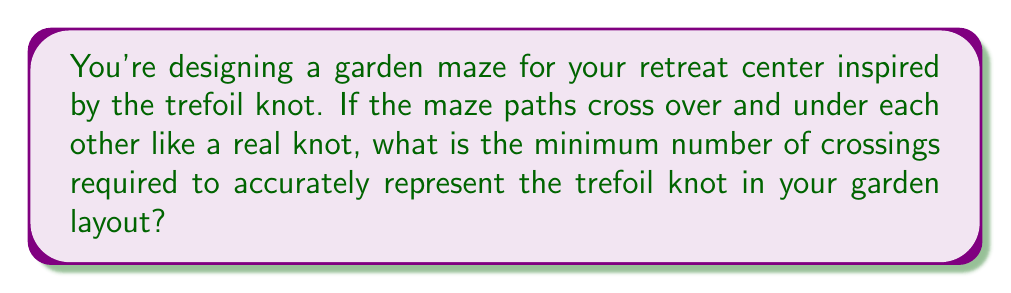Could you help me with this problem? To determine the minimum number of crossings for the trefoil knot-inspired garden maze, we need to consider the crossing number of the trefoil knot in knot theory. Let's approach this step-by-step:

1. The trefoil knot is one of the simplest non-trivial knots in knot theory.

2. In knot theory, the crossing number of a knot is defined as the minimum number of crossings in any diagram of the knot.

3. For the trefoil knot, we can visualize it as follows:

   [asy]
   import geometry;

   size(100);
   pen p = black+1;

   path trefoil = (0,2)..(2,0)..(0,-2)..(-2,0)..cycle;
   draw(trefoil, p);

   dot((0.67,0.67), p+5);
   dot((-0.67,0.67), p+5);
   dot((0,-0.67), p+5);
   [/asy]

4. Counting the crossings in this standard representation, we can see that there are 3 crossings.

5. It's important to note that while we can draw diagrams of the trefoil knot with more than 3 crossings, 3 is the minimum number required.

6. In knot theory, it has been proven that the crossing number of the trefoil knot is indeed 3. This means it's impossible to represent a trefoil knot with fewer than 3 crossings.

Therefore, to accurately represent the trefoil knot in your garden maze layout, you would need a minimum of 3 crossings where the paths go over and under each other.
Answer: 3 